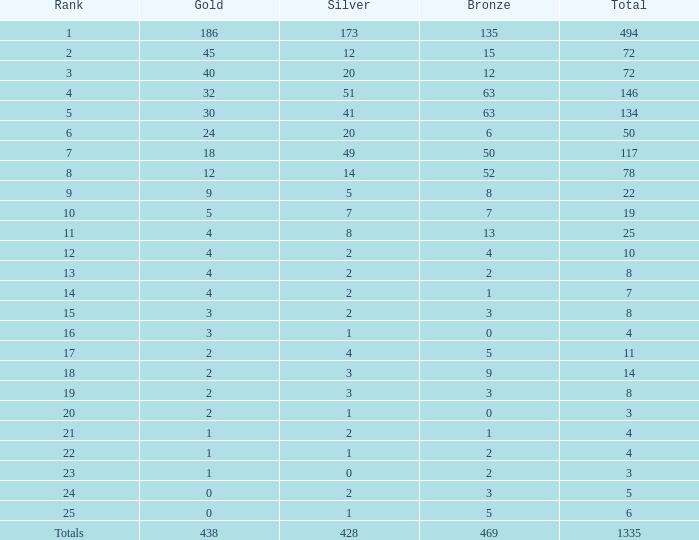How many gold medals were there in total when over 20 silver and 135 bronze medals were given? 1.0. 